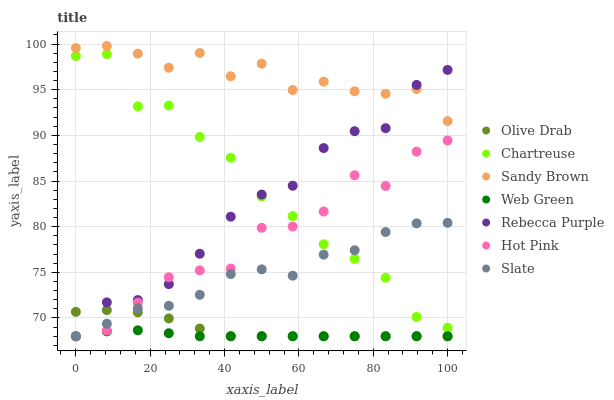Does Web Green have the minimum area under the curve?
Answer yes or no. Yes. Does Sandy Brown have the maximum area under the curve?
Answer yes or no. Yes. Does Hot Pink have the minimum area under the curve?
Answer yes or no. No. Does Hot Pink have the maximum area under the curve?
Answer yes or no. No. Is Web Green the smoothest?
Answer yes or no. Yes. Is Hot Pink the roughest?
Answer yes or no. Yes. Is Hot Pink the smoothest?
Answer yes or no. No. Is Web Green the roughest?
Answer yes or no. No. Does Slate have the lowest value?
Answer yes or no. Yes. Does Chartreuse have the lowest value?
Answer yes or no. No. Does Sandy Brown have the highest value?
Answer yes or no. Yes. Does Hot Pink have the highest value?
Answer yes or no. No. Is Slate less than Sandy Brown?
Answer yes or no. Yes. Is Chartreuse greater than Olive Drab?
Answer yes or no. Yes. Does Web Green intersect Rebecca Purple?
Answer yes or no. Yes. Is Web Green less than Rebecca Purple?
Answer yes or no. No. Is Web Green greater than Rebecca Purple?
Answer yes or no. No. Does Slate intersect Sandy Brown?
Answer yes or no. No. 